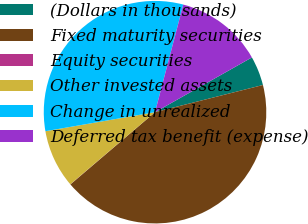<chart> <loc_0><loc_0><loc_500><loc_500><pie_chart><fcel>(Dollars in thousands)<fcel>Fixed maturity securities<fcel>Equity securities<fcel>Other invested assets<fcel>Change in unrealized<fcel>Deferred tax benefit (expense)<nl><fcel>4.26%<fcel>42.68%<fcel>0.02%<fcel>8.49%<fcel>31.82%<fcel>12.73%<nl></chart> 